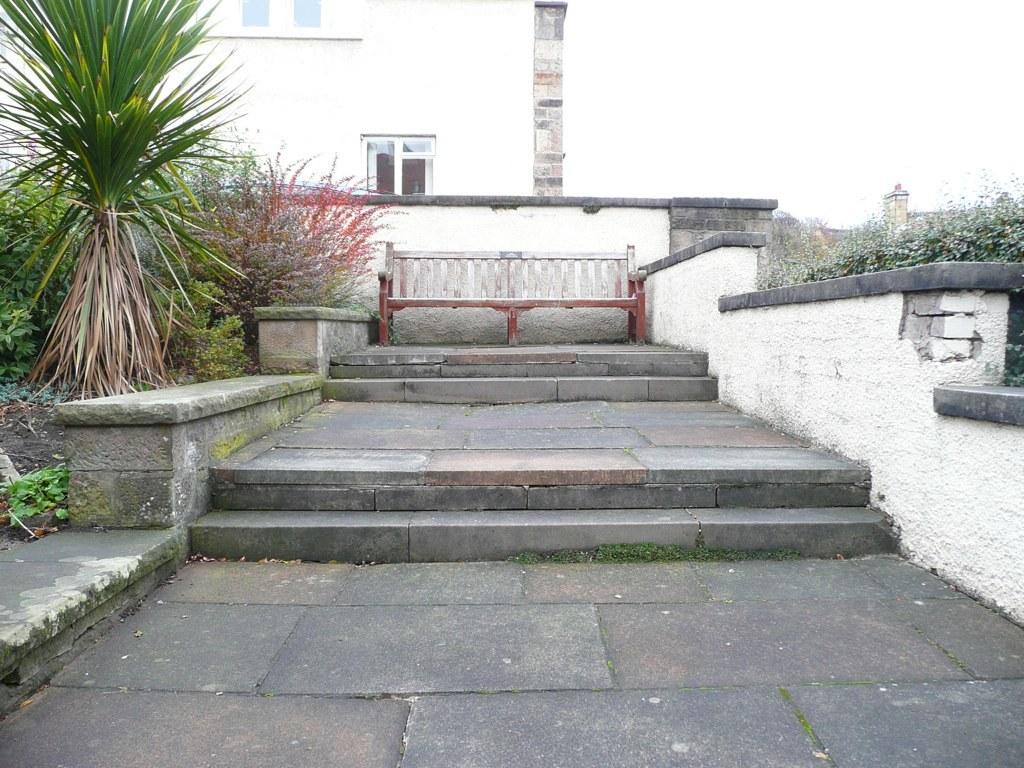What type of structure can be seen in the image? There is a building in the image. What is located near the building? There are steps and a wooden bench in the image. What type of vegetation is present in the image? There are plants in the image. What is the background of the image? The sky is visible in the background of the image. What other architectural feature can be seen in the image? There is a wall in the image. What type of rod is used to clean the account in the image? There is no rod or account present in the image. How many toothbrushes are visible in the image? There are no toothbrushes present in the image. 